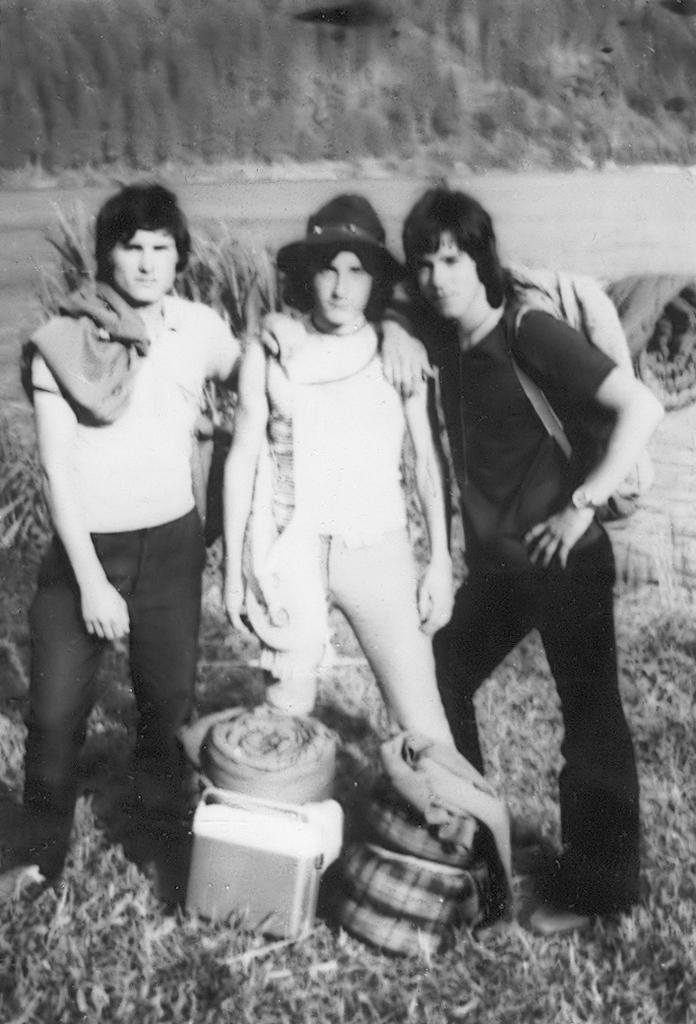How many people are in the image? There are three people in the image. Can you describe the clothing or accessories of one of the people? One of the people is wearing a backpack. What other items can be seen in the image besides the people? There are bags, a box, plants, grass, and trees visible in the image. What type of club is being used to hit the toad in the image? There is no toad or club present in the image. 